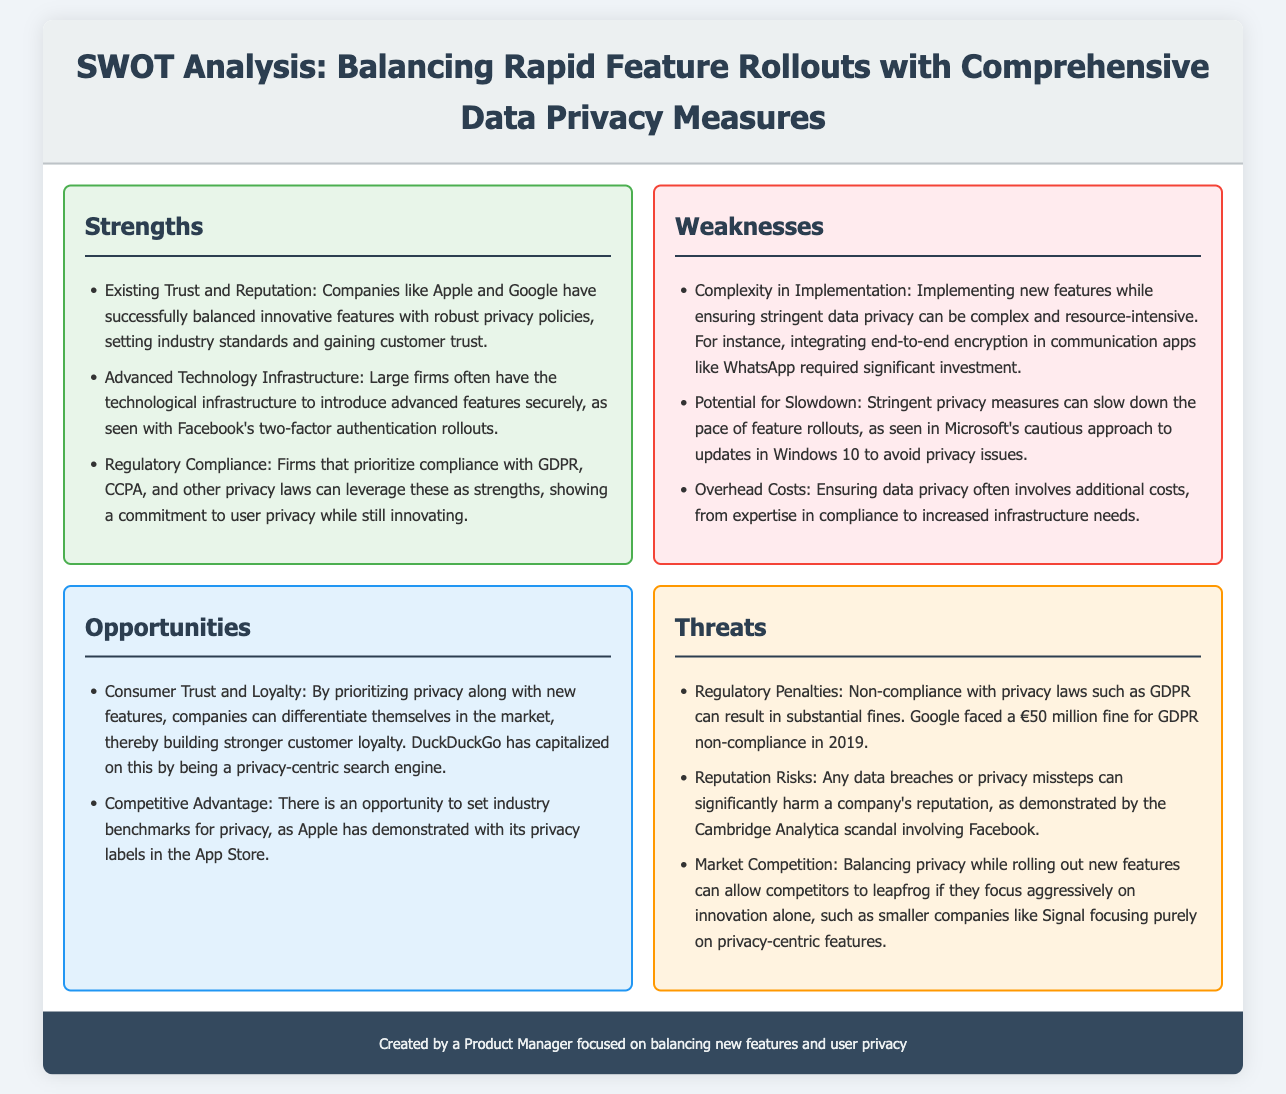What are the strengths identified in the SWOT analysis? The strengths listed in the document include existing trust and reputation in the industry, advanced technology infrastructure, and regulatory compliance with privacy laws.
Answer: Existing Trust and Reputation, Advanced Technology Infrastructure, Regulatory Compliance What is one example of a company that has balanced privacy and innovation? The document mentions Apple and Google as examples of companies successfully balancing innovative features with robust privacy policies.
Answer: Apple and Google What complexity is mentioned as a weakness in the implementation of new features? The document states that implementing new features while ensuring stringent data privacy is complex and resource-intensive.
Answer: Complexity in Implementation What opportunity do companies have by prioritizing privacy? Companies can differentiate themselves in the market by prioritizing privacy, leading to stronger customer loyalty.
Answer: Consumer Trust and Loyalty What regulatory penalty did Google face for GDPR non-compliance? The document notes that Google faced a fine of €50 million for GDPR non-compliance.
Answer: €50 million Which smaller company is mentioned as focusing purely on privacy-centric features? The document references Signal as a smaller company concentrating on privacy-centric features.
Answer: Signal What threat is associated with data breaches according to the SWOT analysis? The analysis states that data breaches or privacy missteps can significantly harm a company's reputation.
Answer: Reputation Risks What is an example of a competitive advantage mentioned? The document cites Apple's privacy labels in the App Store as an opportunity to set industry benchmarks for privacy.
Answer: Privacy labels in the App Store How do companies like DuckDuckGo capitalize on privacy? The document suggests that DuckDuckGo has built a reputation as a privacy-centric search engine to strengthen its market position.
Answer: Privacy-centric search engine 